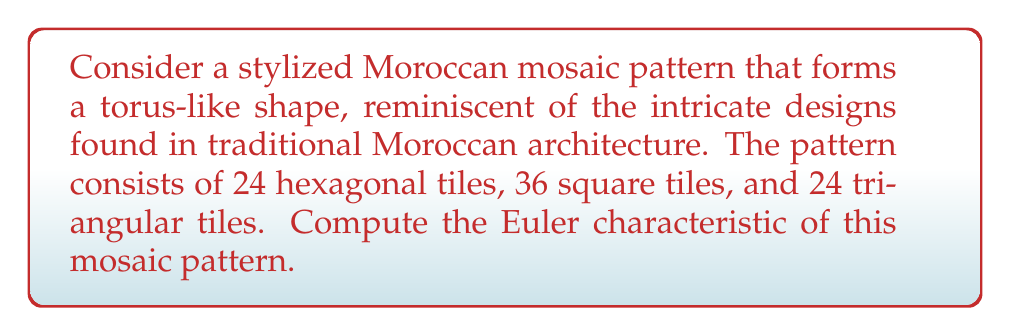Help me with this question. To compute the Euler characteristic of this Moroccan mosaic pattern, we'll use the formula:

$$\chi = V - E + F$$

Where:
$\chi$ is the Euler characteristic
$V$ is the number of vertices
$E$ is the number of edges
$F$ is the number of faces

Let's break down the problem step-by-step:

1. Count the faces (F):
   We're given the number of tiles, which represent the faces:
   - 24 hexagonal tiles
   - 36 square tiles
   - 24 triangular tiles
   Total faces: $F = 24 + 36 + 24 = 84$

2. Count the edges (E):
   - Each hexagon has 6 edges
   - Each square has 4 edges
   - Each triangle has 3 edges
   
   However, each edge is shared by two faces, so we need to divide the total by 2:
   
   $$E = \frac{(24 \times 6) + (36 \times 4) + (24 \times 3)}{2} = \frac{144 + 144 + 72}{2} = 180$$

3. Count the vertices (V):
   We can use the Euler-Poincaré formula for a torus:
   
   $$V - E + F = 0$$
   
   Rearranging to solve for V:
   
   $$V = E - F = 180 - 84 = 96$$

Now we have all the components to calculate the Euler characteristic:

$$\chi = V - E + F = 96 - 180 + 84 = 0$$

This result of 0 is consistent with the Euler characteristic of a torus, which confirms that our Moroccan mosaic pattern indeed forms a torus-like shape.
Answer: $\chi = 0$ 